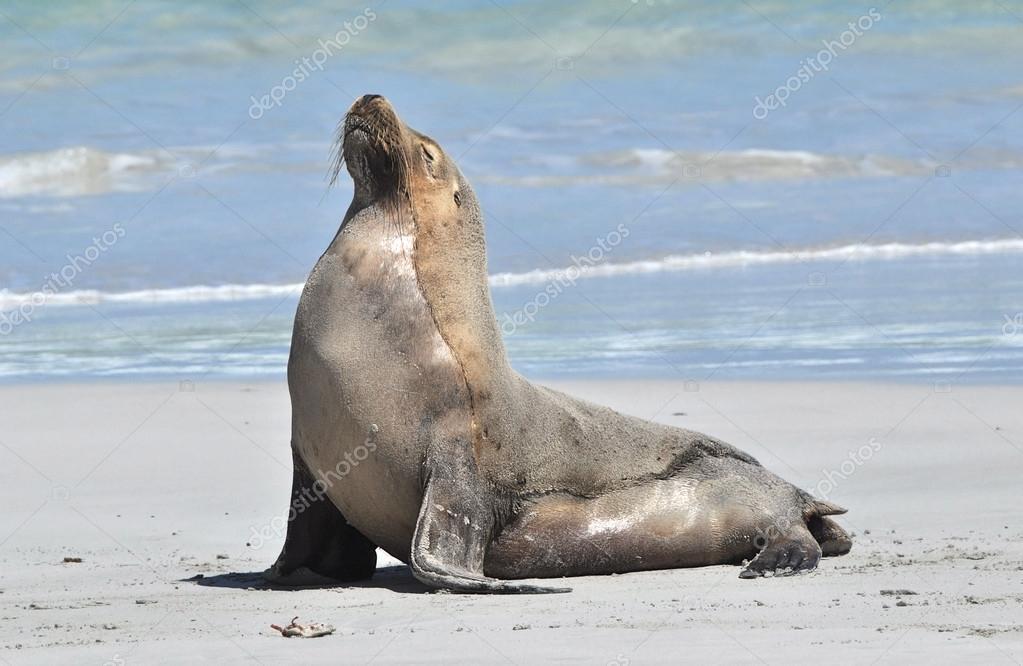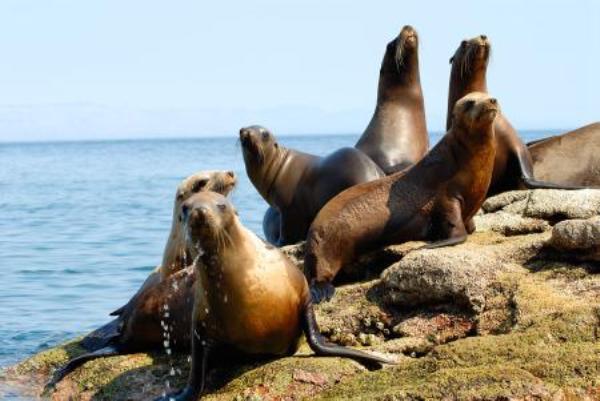The first image is the image on the left, the second image is the image on the right. For the images displayed, is the sentence "Each image contains one aquatic mammal perched on a rock, with upraised head and wet hide, and the animals in the left and right images face different directions." factually correct? Answer yes or no. No. 